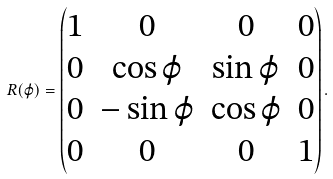<formula> <loc_0><loc_0><loc_500><loc_500>R ( \varphi ) = \left ( \begin{matrix} 1 & 0 & 0 & 0 \\ 0 & \cos \varphi & \sin \varphi & 0 \\ 0 & - \sin \varphi & \cos \varphi & 0 \\ 0 & 0 & 0 & 1 \end{matrix} \right ) .</formula> 